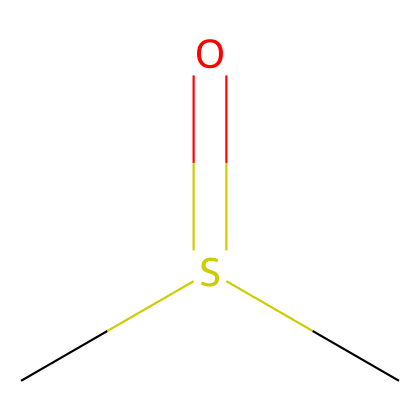What is the molecular formula of this compound? The SMILES notation indicates the number of carbon (C), sulfur (S), and oxygen (O) atoms. The notation "CS(=O)C" shows two carbon atoms, one sulfur atom, and one oxygen atom, leading to the molecular formula C2H6OS.
Answer: C2H6OS How many hydrogen atoms are in dimethyl sulfoxide (DMSO)? Looking at the SMILES representation "CS(=O)C," each methyl group (C) is bonded to three hydrogen atoms. Since there are two carbon atoms involved, the total number of hydrogen atoms is calculated as 3 (from one methyl) + 3 (from the second methyl) = 6.
Answer: 6 What type of bonding is present in DMSO? The structure shows single bonds between carbon and hydrogen atoms and a double bond between sulfur and oxygen (the =O), indicating both single and double bonding.
Answer: single and double bonds Is DMSO a polar or nonpolar compound? The presence of the polar sulfoxide group (S=O), which can engage in hydrogen bonding, makes the overall molecule polar, despite the presence of nonpolar methyl groups.
Answer: polar What is the functional group in DMSO? In the given structure, the "S(=O)" indicates the presence of a sulfoxide functional group in the compound. The sulfur is bonded to one oxygen with a double bond and it is the defining feature of DMSO.
Answer: sulfoxide What role does the sulfur atom play in DMSO? The sulfur atom in DMSO serves as a central atom that connects the two methyl groups and the oxygen atom. It contributes to the compound's unique properties, including its solubility and ability to penetrate biological membranes.
Answer: central atom How does DMSO interact with other molecules? DMSO's polar nature due to the sulfoxide group allows it to dissolve a variety of polar and nonpolar compounds, making it an excellent solvent and penetrant in biological systems.
Answer: solvent and penetrant 